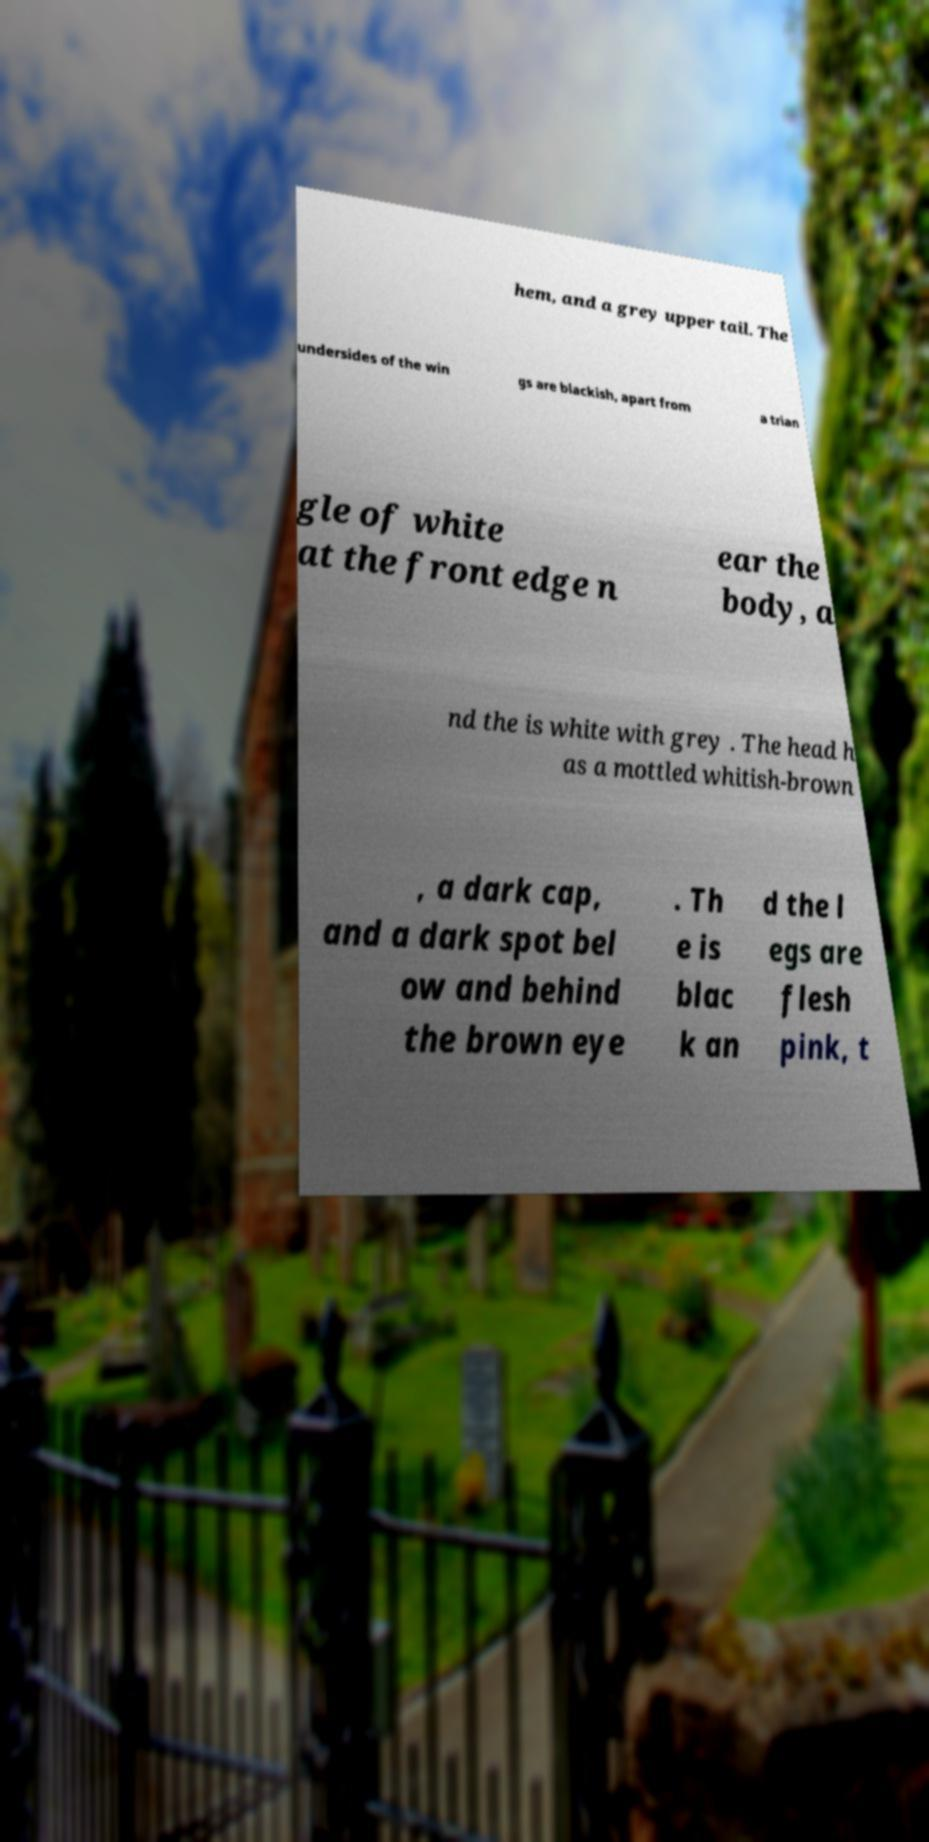There's text embedded in this image that I need extracted. Can you transcribe it verbatim? hem, and a grey upper tail. The undersides of the win gs are blackish, apart from a trian gle of white at the front edge n ear the body, a nd the is white with grey . The head h as a mottled whitish-brown , a dark cap, and a dark spot bel ow and behind the brown eye . Th e is blac k an d the l egs are flesh pink, t 